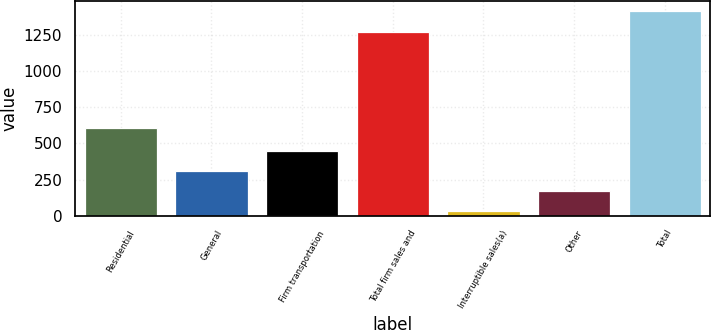<chart> <loc_0><loc_0><loc_500><loc_500><bar_chart><fcel>Residential<fcel>General<fcel>Firm transportation<fcel>Total firm sales and<fcel>Interruptible sales(a)<fcel>Other<fcel>Total<nl><fcel>607<fcel>311<fcel>449<fcel>1269<fcel>35<fcel>173<fcel>1415<nl></chart> 